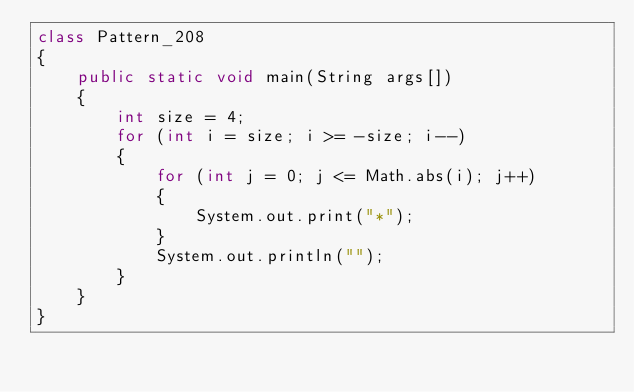Convert code to text. <code><loc_0><loc_0><loc_500><loc_500><_Java_>class Pattern_208
{
    public static void main(String args[])
    {
        int size = 4;
        for (int i = size; i >= -size; i--)
        {
            for (int j = 0; j <= Math.abs(i); j++)
            {
                System.out.print("*");
            }
            System.out.println("");
        }
    }
}</code> 